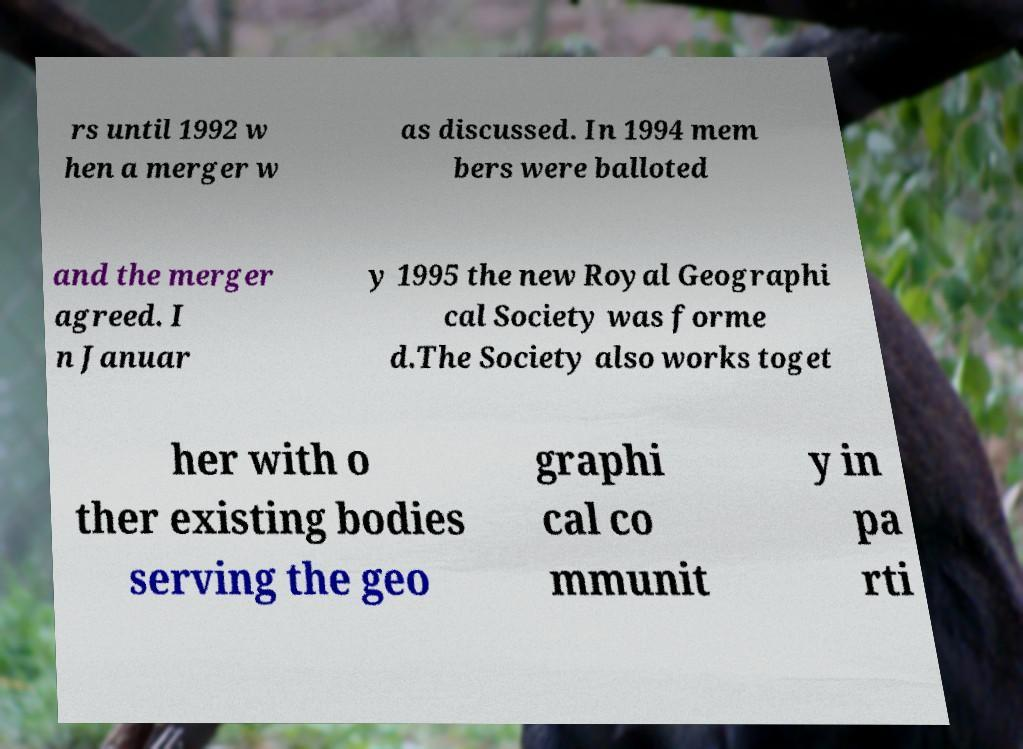For documentation purposes, I need the text within this image transcribed. Could you provide that? rs until 1992 w hen a merger w as discussed. In 1994 mem bers were balloted and the merger agreed. I n Januar y 1995 the new Royal Geographi cal Society was forme d.The Society also works toget her with o ther existing bodies serving the geo graphi cal co mmunit y in pa rti 